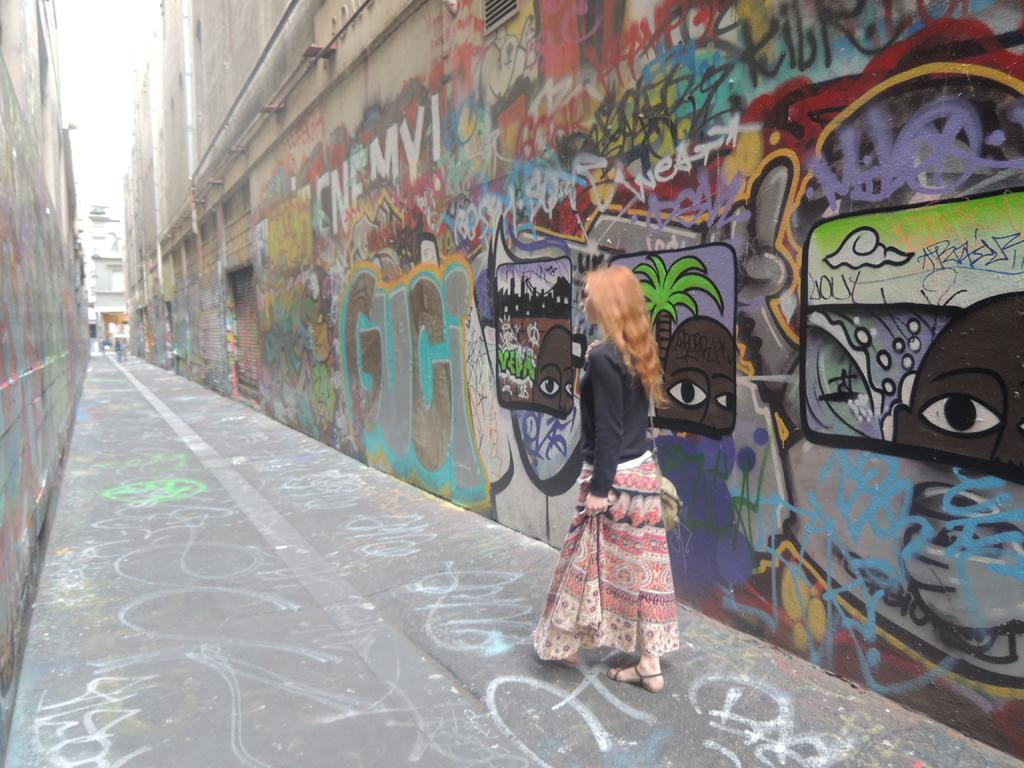What are the people in the image doing? The people in the image are walking on a path. What can be seen on both sides of the path? There are buildings on both sides of the path in the image. What type of surface is visible on the walls in the image? The walls in the image have a painted surface. What type of party is being held in the image? There is no party visible in the image; it shows people walking on a path with buildings on both sides. What is the title of the image? The provided facts do not include a title for the image. 